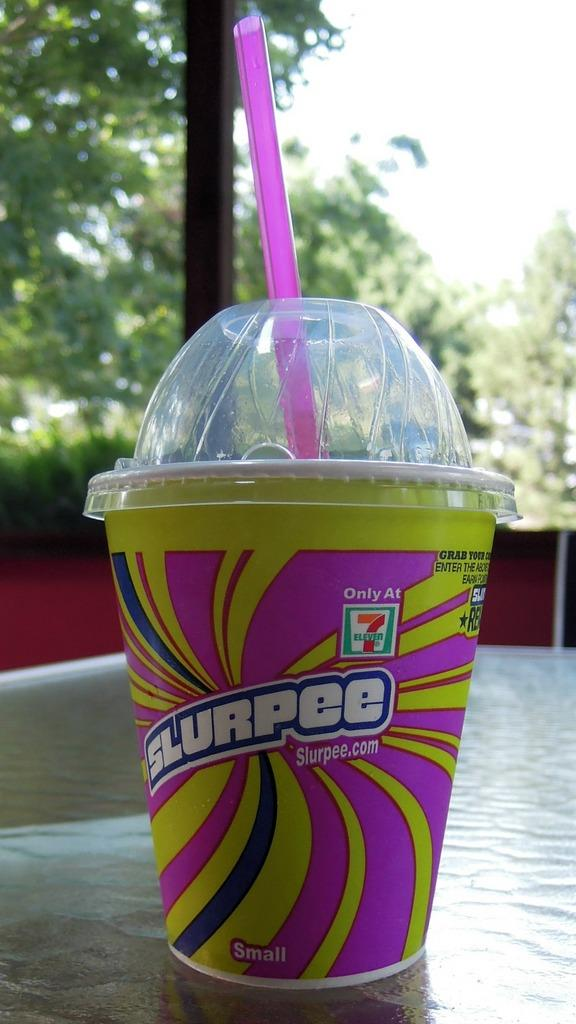What is on the table in the image? There is a paper glass on a table in the image. What is inside the paper glass? There is a straw in the paper glass. What can be seen in the background of the image? There are many trees in the background of the image. What is visible at the top of the image? The sky is visible at the top of the image. How does the fork start the engine in the image? There is no fork or engine present in the image. What type of fog can be seen in the image? There is no fog present in the image; the sky is visible at the top. 